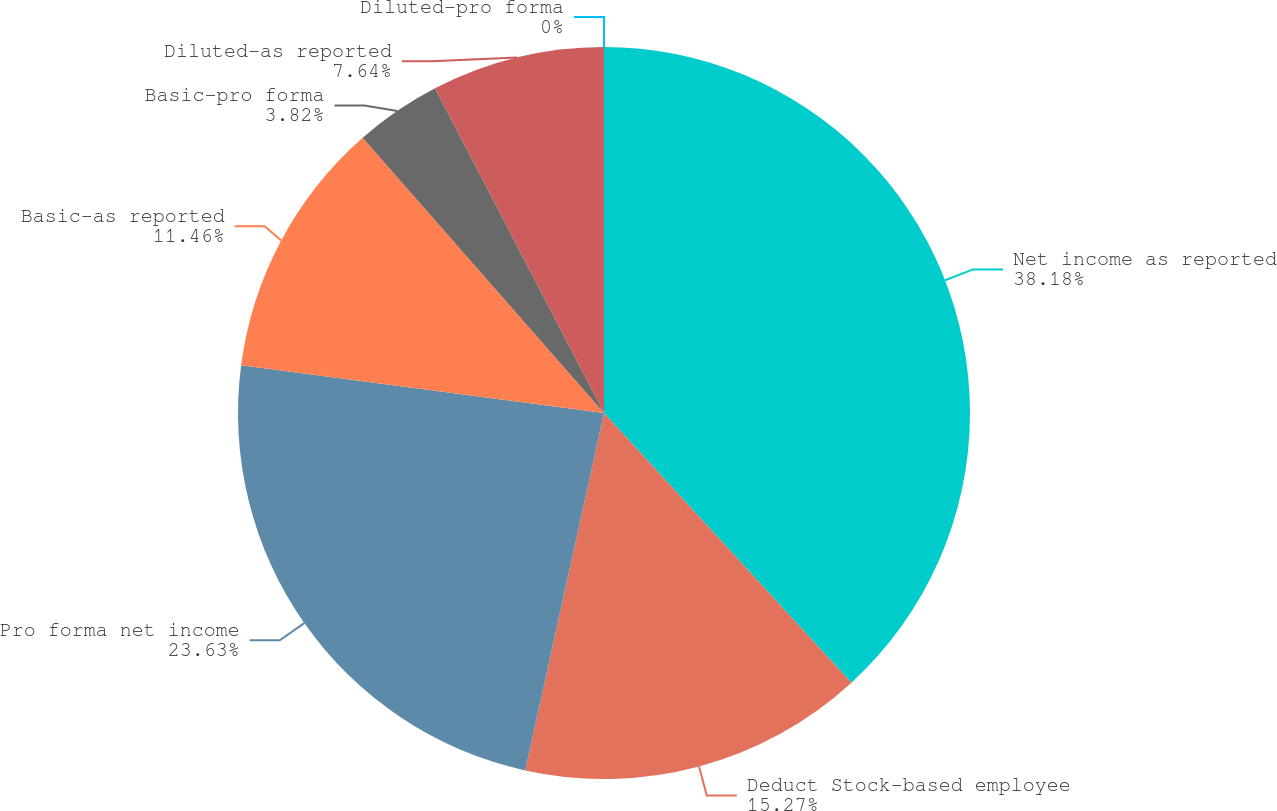Convert chart to OTSL. <chart><loc_0><loc_0><loc_500><loc_500><pie_chart><fcel>Net income as reported<fcel>Deduct Stock-based employee<fcel>Pro forma net income<fcel>Basic-as reported<fcel>Basic-pro forma<fcel>Diluted-as reported<fcel>Diluted-pro forma<nl><fcel>38.19%<fcel>15.27%<fcel>23.63%<fcel>11.46%<fcel>3.82%<fcel>7.64%<fcel>0.0%<nl></chart> 